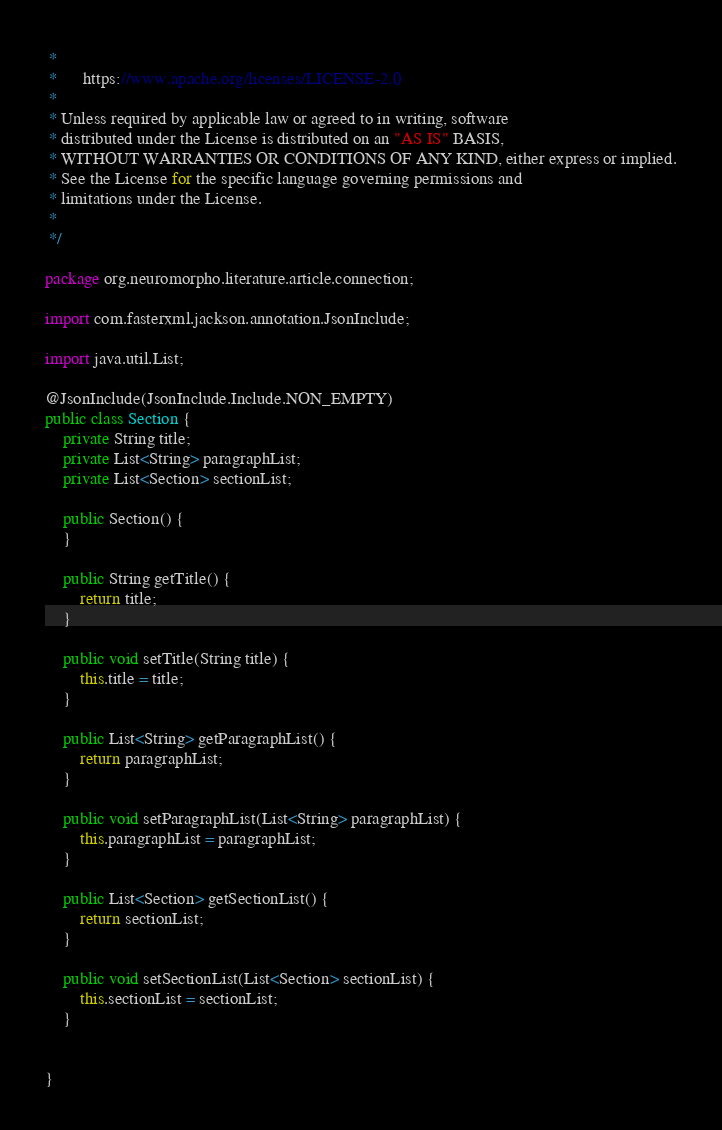Convert code to text. <code><loc_0><loc_0><loc_500><loc_500><_Java_> *
 *      https://www.apache.org/licenses/LICENSE-2.0
 *
 * Unless required by applicable law or agreed to in writing, software
 * distributed under the License is distributed on an "AS IS" BASIS,
 * WITHOUT WARRANTIES OR CONDITIONS OF ANY KIND, either express or implied.
 * See the License for the specific language governing permissions and
 * limitations under the License.
 *  
 */

package org.neuromorpho.literature.article.connection;

import com.fasterxml.jackson.annotation.JsonInclude;

import java.util.List;

@JsonInclude(JsonInclude.Include.NON_EMPTY)
public class Section {
    private String title;
    private List<String> paragraphList;
    private List<Section> sectionList;

    public Section() {
    }

    public String getTitle() {
        return title;
    }

    public void setTitle(String title) {
        this.title = title;
    }

    public List<String> getParagraphList() {
        return paragraphList;
    }

    public void setParagraphList(List<String> paragraphList) {
        this.paragraphList = paragraphList;
    }

    public List<Section> getSectionList() {
        return sectionList;
    }

    public void setSectionList(List<Section> sectionList) {
        this.sectionList = sectionList;
    }
    

}
</code> 